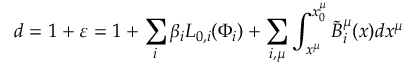Convert formula to latex. <formula><loc_0><loc_0><loc_500><loc_500>d = 1 + \varepsilon = 1 + \sum _ { i } { \beta _ { i } L _ { 0 , i } ( \Phi _ { i } ) } + \sum _ { i , \mu } { \int _ { x ^ { \mu } } ^ { x _ { 0 } ^ { \mu } } { \tilde { B } _ { i } ^ { \mu } ( x ) d x ^ { \mu } } }</formula> 